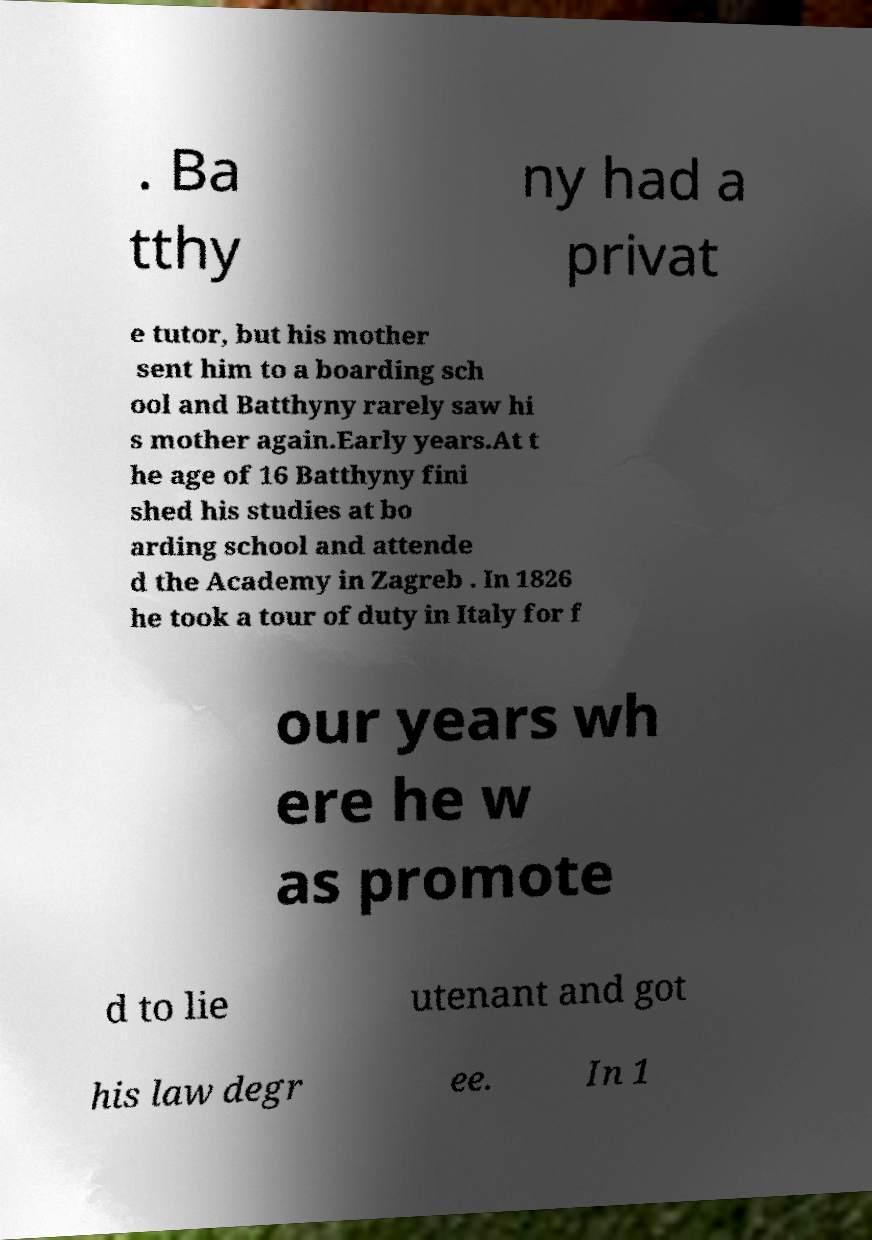Could you extract and type out the text from this image? . Ba tthy ny had a privat e tutor, but his mother sent him to a boarding sch ool and Batthyny rarely saw hi s mother again.Early years.At t he age of 16 Batthyny fini shed his studies at bo arding school and attende d the Academy in Zagreb . In 1826 he took a tour of duty in Italy for f our years wh ere he w as promote d to lie utenant and got his law degr ee. In 1 